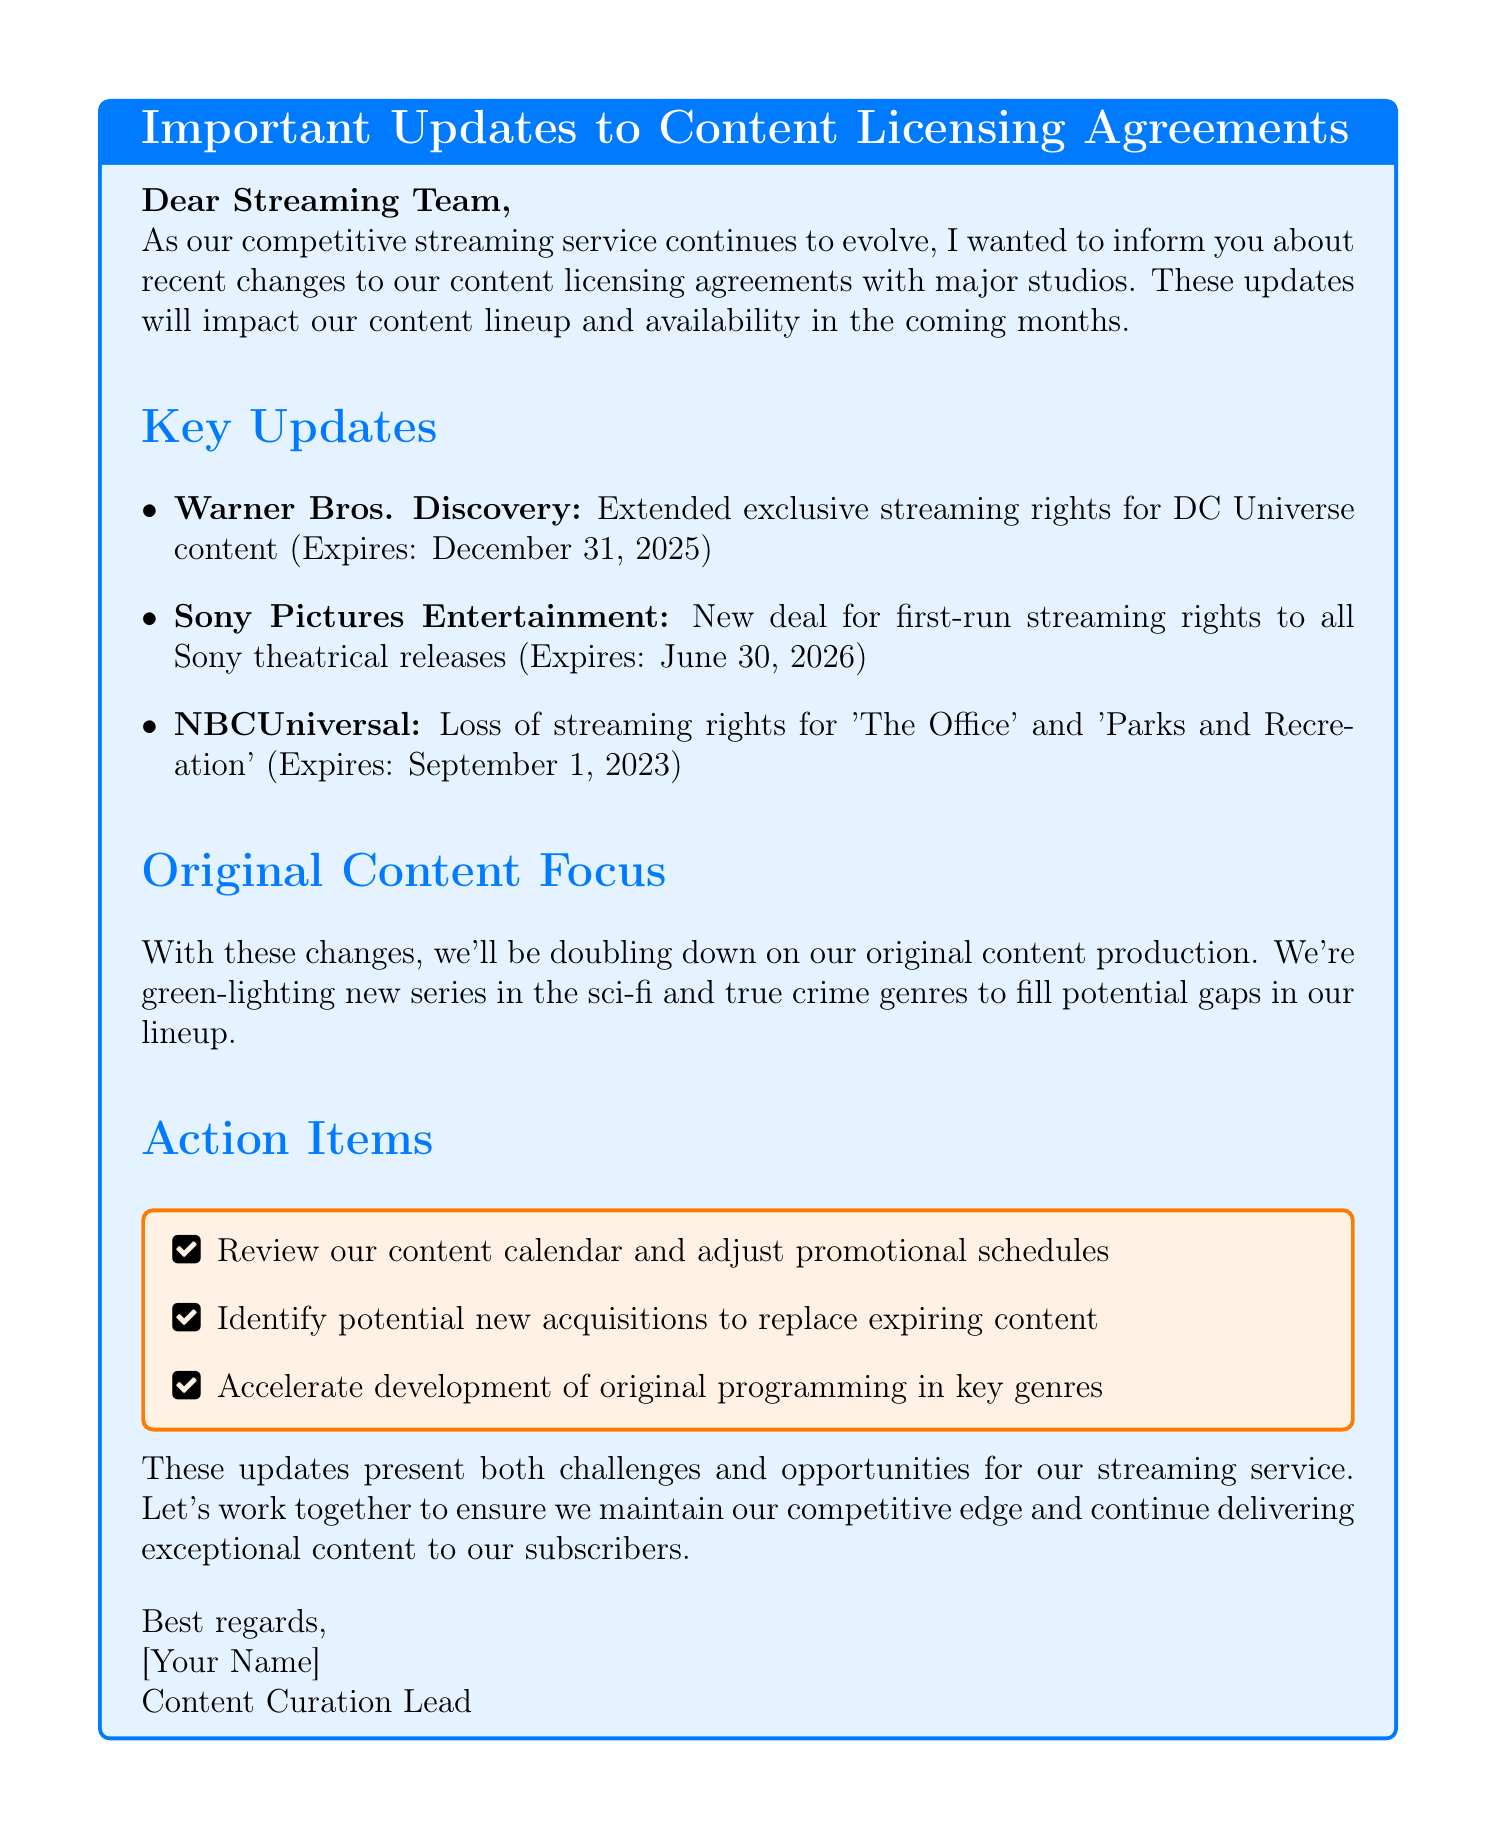What is the subject of the email? The subject line of the email provides a clear indication of what the email is addressing.
Answer: Important Updates to Content Licensing Agreements What studio is losing streaming rights for 'The Office'? This specific studio is named in the key updates section of the document.
Answer: NBCUniversal When do the exclusive streaming rights for DC Universe content expire? The expiration date is mentioned alongside the update for Warner Bros. Discovery.
Answer: December 31, 2025 What type of new series is being green-lit? The email outlines areas of focus in the original content production section, highlighting key genres.
Answer: Sci-fi and true crime What is one of the action items listed in the email? The action items are listed in a box emphasizing what needs to be done, and several are noted in the document.
Answer: Review our content calendar and adjust promotional schedules How long are the new first-run streaming rights with Sony Pictures Entertainment valid? This question requires combining information from the updates section regarding the time frame.
Answer: June 30, 2026 What is the primary focus outlined in the original content section? It emphasizes the intent to enhance our service's offerings in light of changes to licensing.
Answer: Doubling down on original content production How does the email suggest handling expiring content? It suggests identifying potential replacements as part of the action items.
Answer: Identify potential new acquisitions to replace expiring content What phrase is used to describe the changes as a whole? The closing remarks encapsulate the overall sentiment expressed in the email.
Answer: Challenges and opportunities 